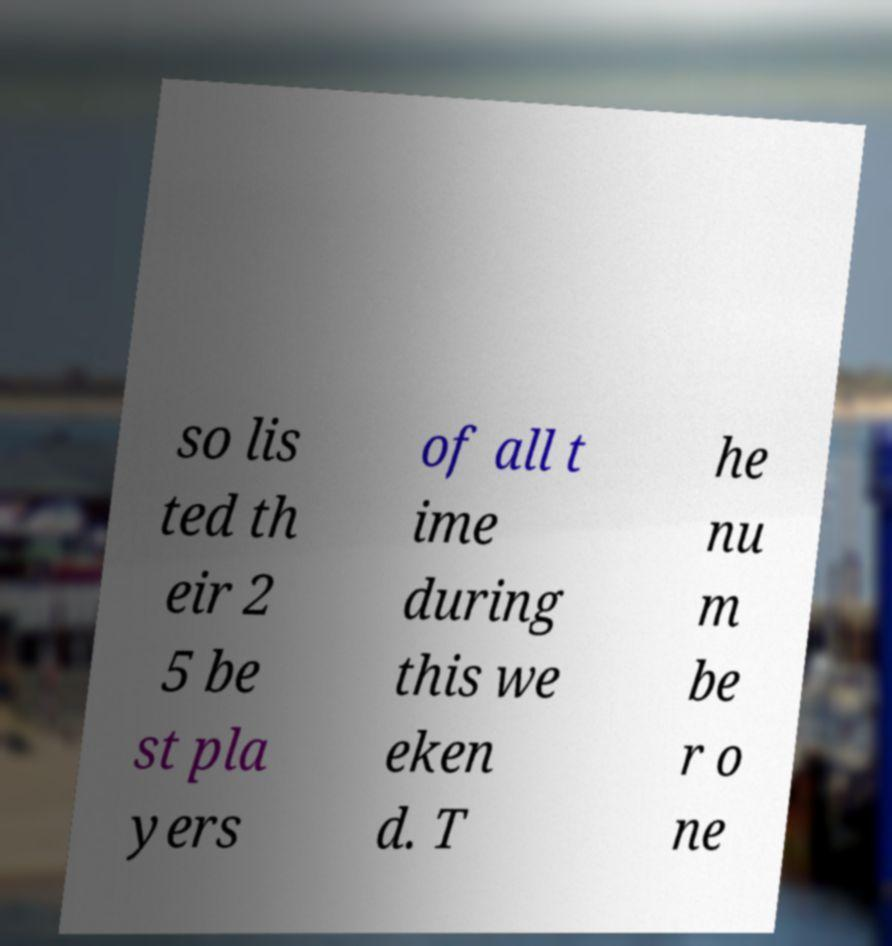Please identify and transcribe the text found in this image. so lis ted th eir 2 5 be st pla yers of all t ime during this we eken d. T he nu m be r o ne 